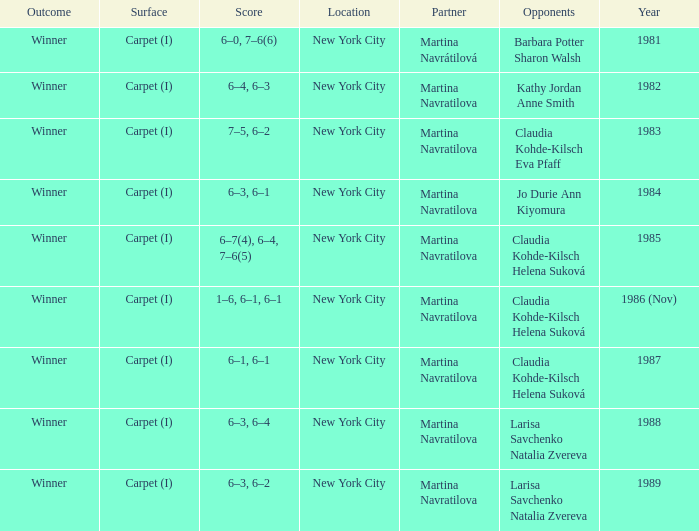What was the outcome for the match in 1989? Winner. 